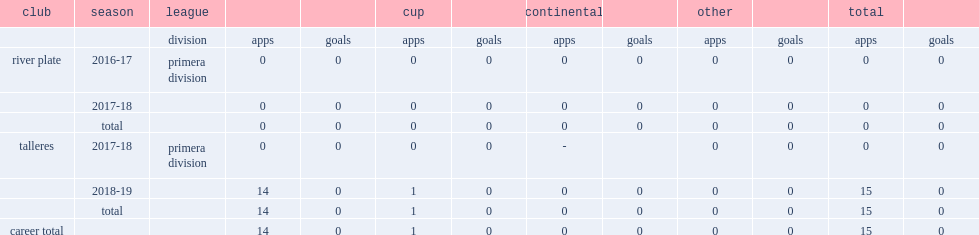Which club did medina play for in 2016-17? River plate. 